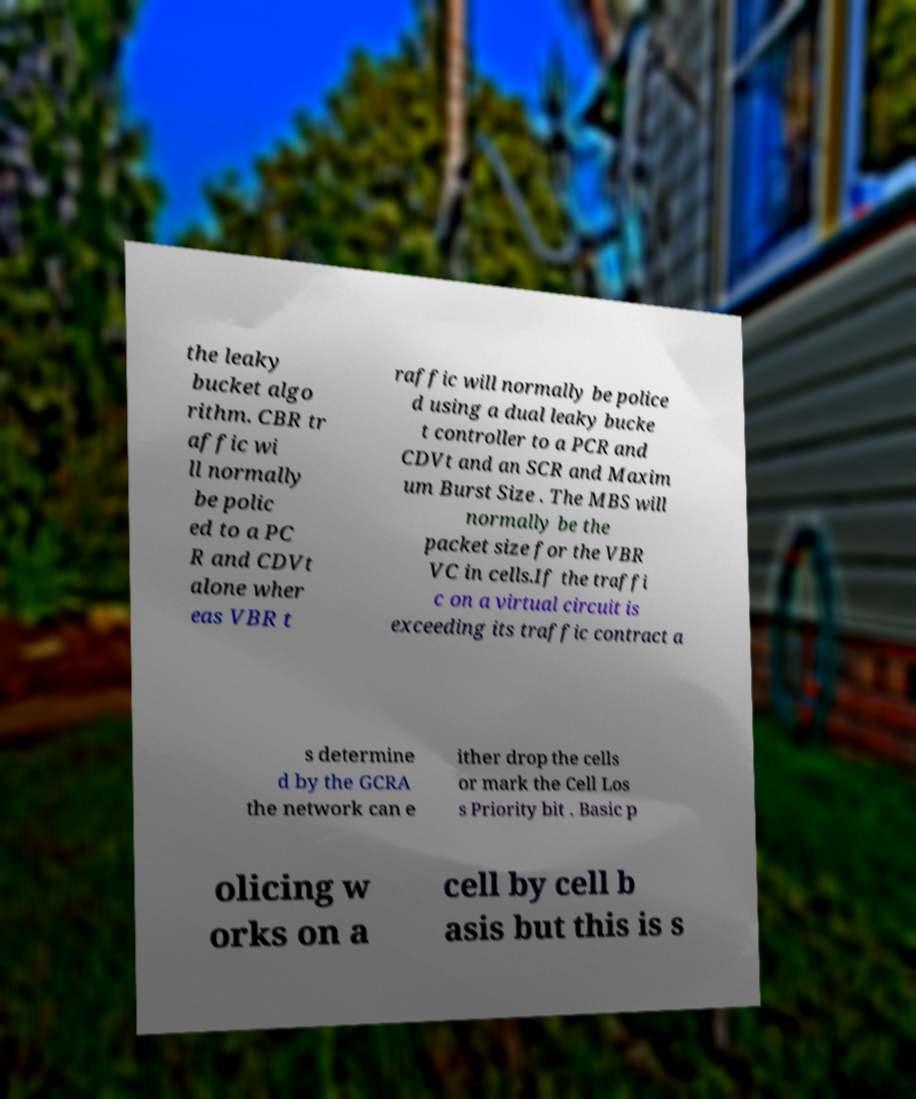Can you read and provide the text displayed in the image?This photo seems to have some interesting text. Can you extract and type it out for me? the leaky bucket algo rithm. CBR tr affic wi ll normally be polic ed to a PC R and CDVt alone wher eas VBR t raffic will normally be police d using a dual leaky bucke t controller to a PCR and CDVt and an SCR and Maxim um Burst Size . The MBS will normally be the packet size for the VBR VC in cells.If the traffi c on a virtual circuit is exceeding its traffic contract a s determine d by the GCRA the network can e ither drop the cells or mark the Cell Los s Priority bit . Basic p olicing w orks on a cell by cell b asis but this is s 